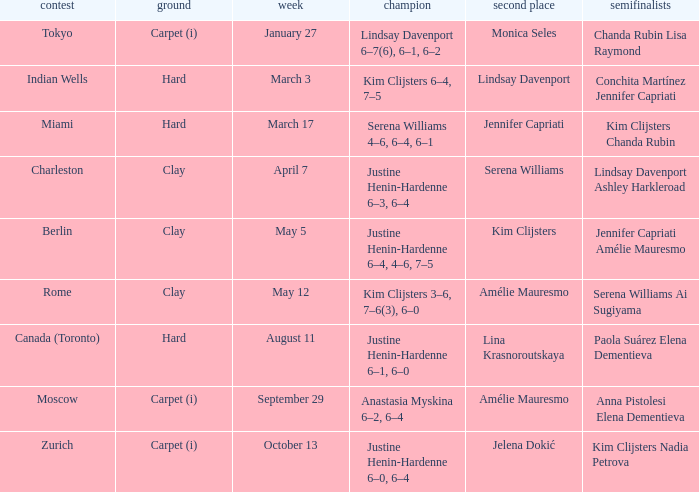Can you parse all the data within this table? {'header': ['contest', 'ground', 'week', 'champion', 'second place', 'semifinalists'], 'rows': [['Tokyo', 'Carpet (i)', 'January 27', 'Lindsay Davenport 6–7(6), 6–1, 6–2', 'Monica Seles', 'Chanda Rubin Lisa Raymond'], ['Indian Wells', 'Hard', 'March 3', 'Kim Clijsters 6–4, 7–5', 'Lindsay Davenport', 'Conchita Martínez Jennifer Capriati'], ['Miami', 'Hard', 'March 17', 'Serena Williams 4–6, 6–4, 6–1', 'Jennifer Capriati', 'Kim Clijsters Chanda Rubin'], ['Charleston', 'Clay', 'April 7', 'Justine Henin-Hardenne 6–3, 6–4', 'Serena Williams', 'Lindsay Davenport Ashley Harkleroad'], ['Berlin', 'Clay', 'May 5', 'Justine Henin-Hardenne 6–4, 4–6, 7–5', 'Kim Clijsters', 'Jennifer Capriati Amélie Mauresmo'], ['Rome', 'Clay', 'May 12', 'Kim Clijsters 3–6, 7–6(3), 6–0', 'Amélie Mauresmo', 'Serena Williams Ai Sugiyama'], ['Canada (Toronto)', 'Hard', 'August 11', 'Justine Henin-Hardenne 6–1, 6–0', 'Lina Krasnoroutskaya', 'Paola Suárez Elena Dementieva'], ['Moscow', 'Carpet (i)', 'September 29', 'Anastasia Myskina 6–2, 6–4', 'Amélie Mauresmo', 'Anna Pistolesi Elena Dementieva'], ['Zurich', 'Carpet (i)', 'October 13', 'Justine Henin-Hardenne 6–0, 6–4', 'Jelena Dokić', 'Kim Clijsters Nadia Petrova']]} Who was the finalist in Miami? Jennifer Capriati. 